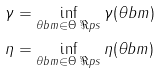Convert formula to latex. <formula><loc_0><loc_0><loc_500><loc_500>\gamma & = \inf _ { \theta b m \in \Theta \ \Re p s } \gamma ( \theta b m ) \\ \eta & = \inf _ { \theta b m \in \Theta \ \Re p s } \eta ( \theta b m )</formula> 